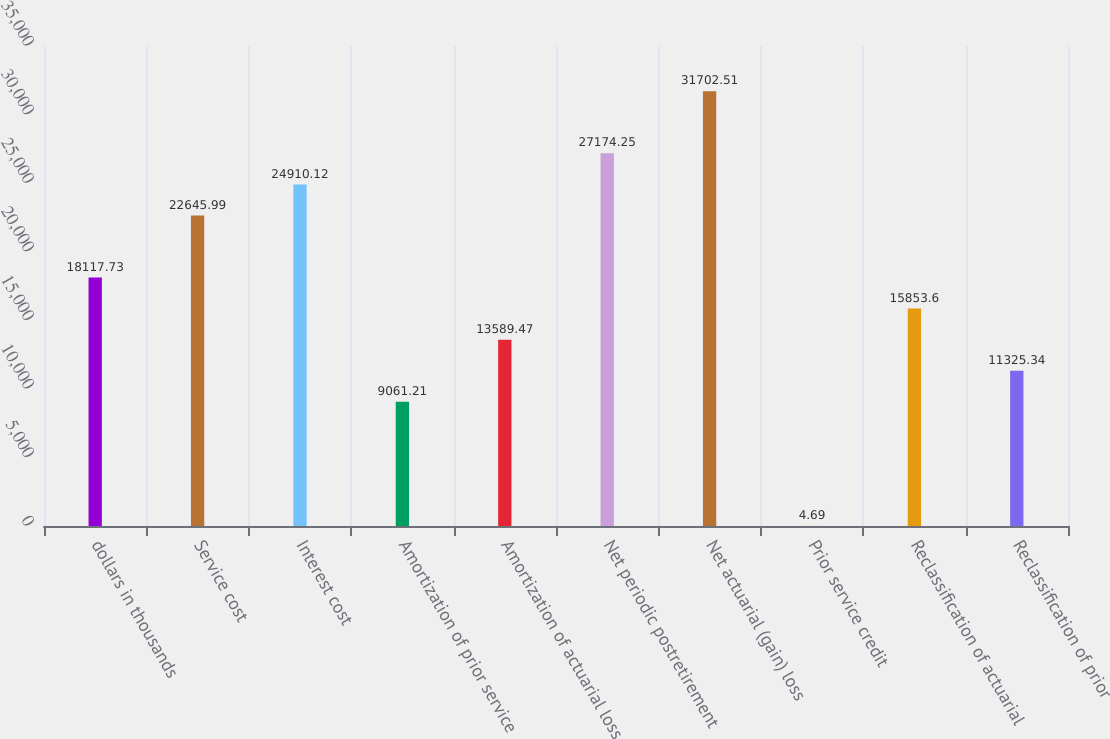<chart> <loc_0><loc_0><loc_500><loc_500><bar_chart><fcel>dollars in thousands<fcel>Service cost<fcel>Interest cost<fcel>Amortization of prior service<fcel>Amortization of actuarial loss<fcel>Net periodic postretirement<fcel>Net actuarial (gain) loss<fcel>Prior service credit<fcel>Reclassification of actuarial<fcel>Reclassification of prior<nl><fcel>18117.7<fcel>22646<fcel>24910.1<fcel>9061.21<fcel>13589.5<fcel>27174.2<fcel>31702.5<fcel>4.69<fcel>15853.6<fcel>11325.3<nl></chart> 